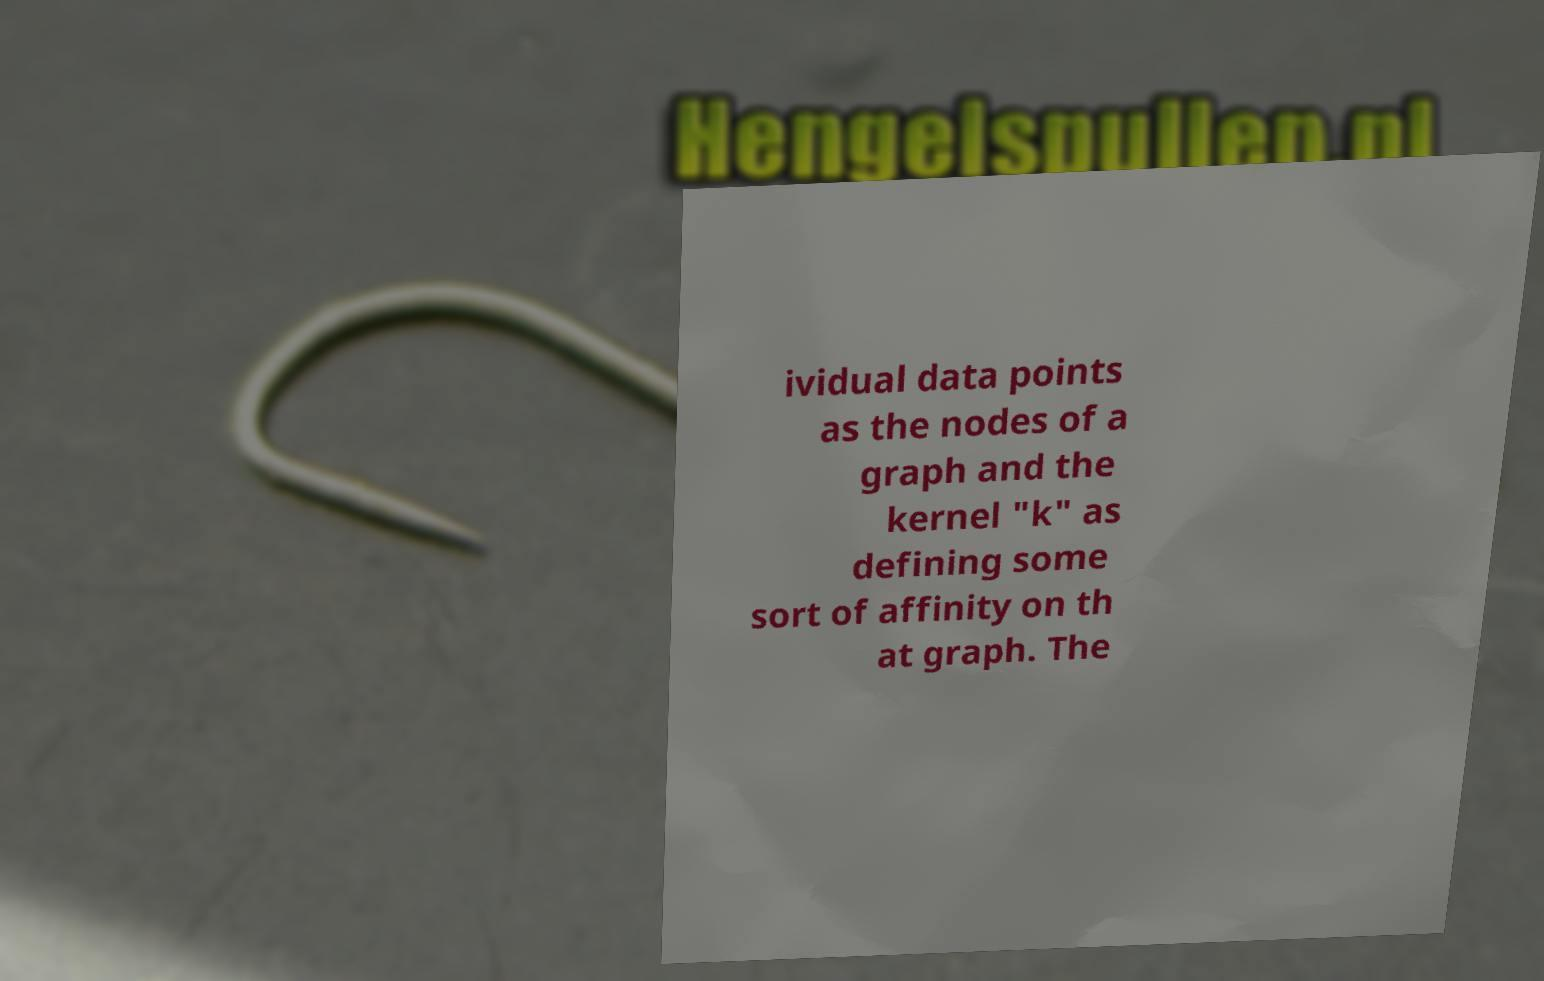Could you extract and type out the text from this image? ividual data points as the nodes of a graph and the kernel "k" as defining some sort of affinity on th at graph. The 